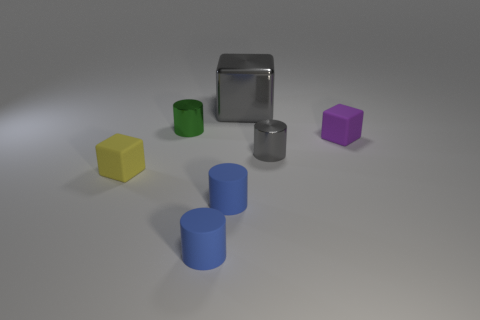Subtract all green metallic cylinders. How many cylinders are left? 3 Subtract all green cylinders. How many cylinders are left? 3 Subtract all brown cylinders. Subtract all brown spheres. How many cylinders are left? 4 Add 3 big matte cylinders. How many objects exist? 10 Subtract all blocks. How many objects are left? 4 Add 5 shiny cubes. How many shiny cubes exist? 6 Subtract 0 red balls. How many objects are left? 7 Subtract all purple blocks. Subtract all gray cylinders. How many objects are left? 5 Add 1 tiny gray shiny cylinders. How many tiny gray shiny cylinders are left? 2 